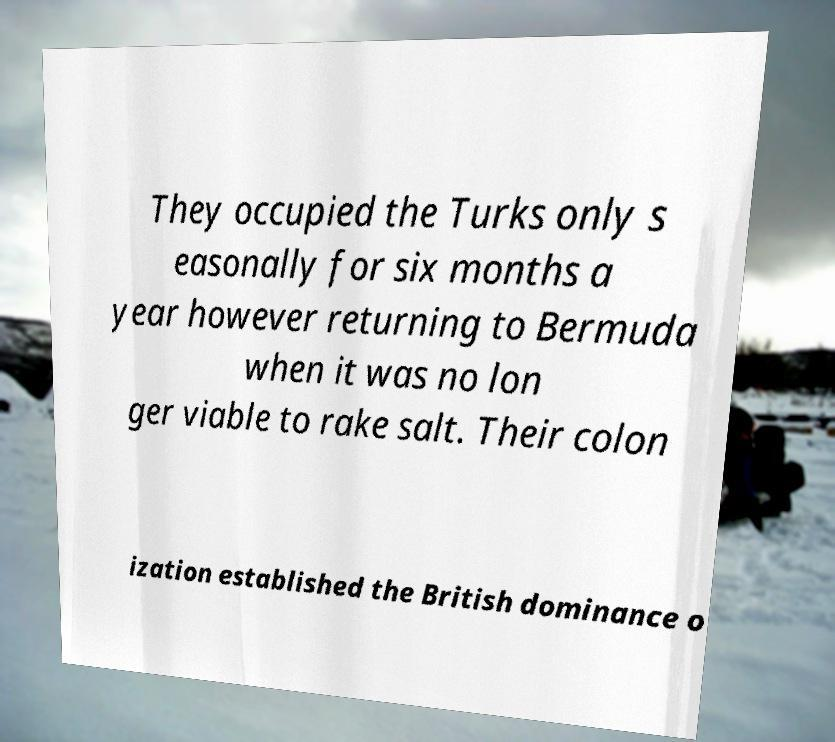There's text embedded in this image that I need extracted. Can you transcribe it verbatim? They occupied the Turks only s easonally for six months a year however returning to Bermuda when it was no lon ger viable to rake salt. Their colon ization established the British dominance o 